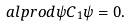Convert formula to latex. <formula><loc_0><loc_0><loc_500><loc_500>a l p r o d { \psi } { C _ { 1 } \psi } = 0 .</formula> 